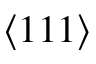<formula> <loc_0><loc_0><loc_500><loc_500>\langle 1 1 1 \rangle</formula> 